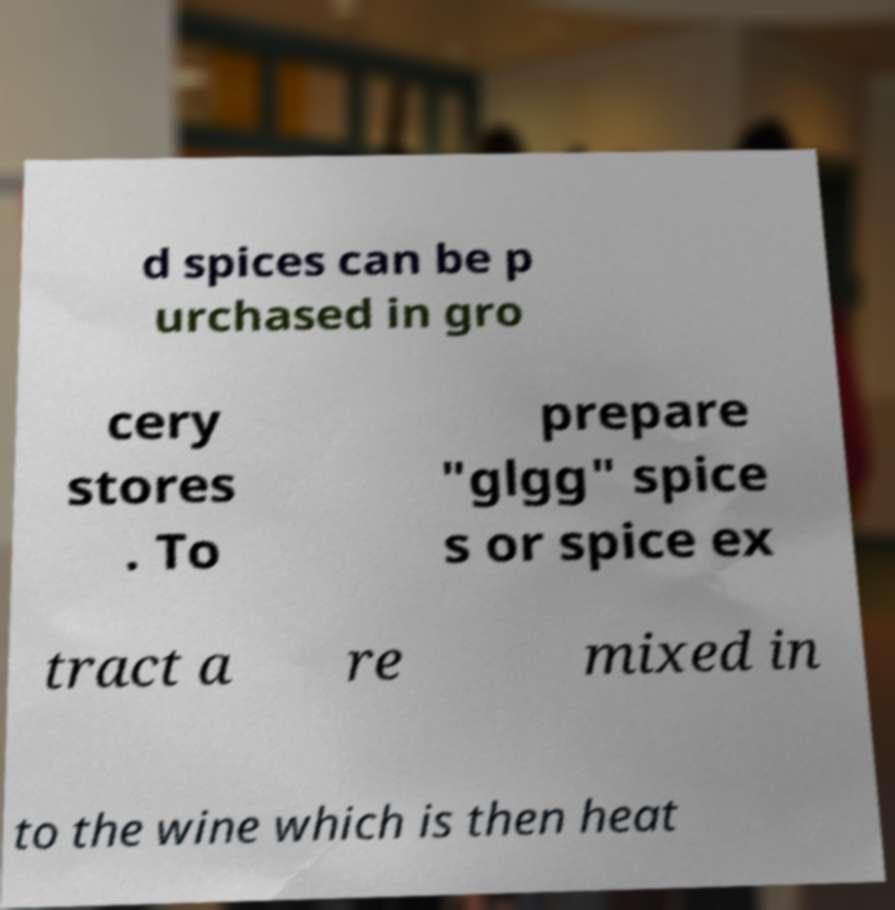I need the written content from this picture converted into text. Can you do that? d spices can be p urchased in gro cery stores . To prepare "glgg" spice s or spice ex tract a re mixed in to the wine which is then heat 